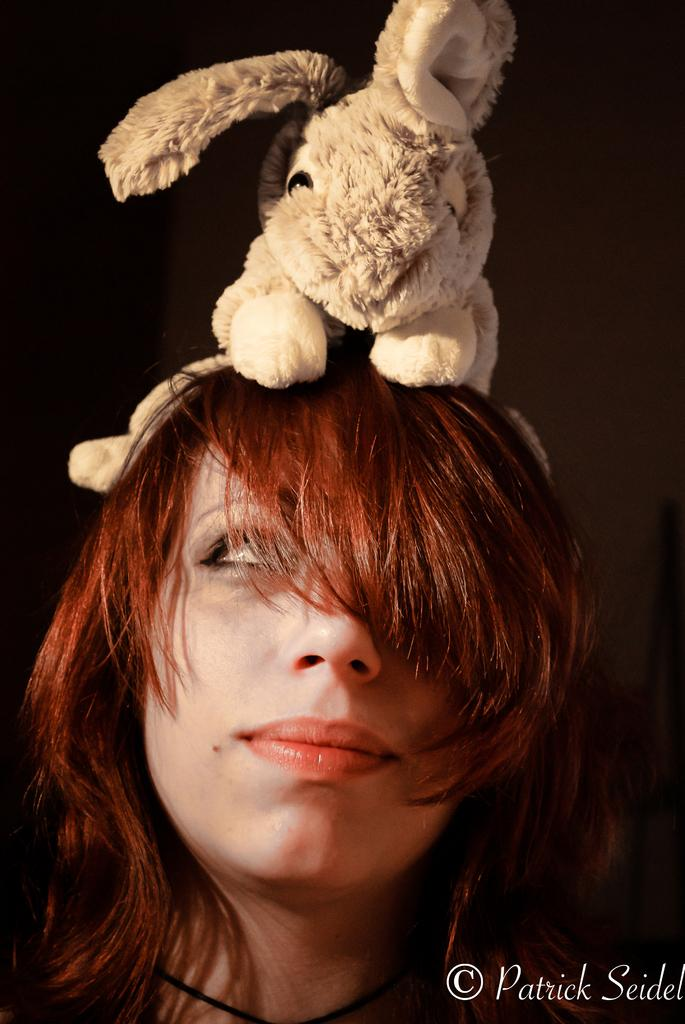Who is the main subject in the image? There is a woman in the image. What is on the woman's head? The woman has a rabbit toy on her head. What color is the background of the image? The background of the image is black. What type of drink is the woman holding in the image? There is no drink visible in the image; the woman has a rabbit toy on her head. Can you tell me how many berries are on the rabbit toy? There are no berries present on the rabbit toy or in the image. 